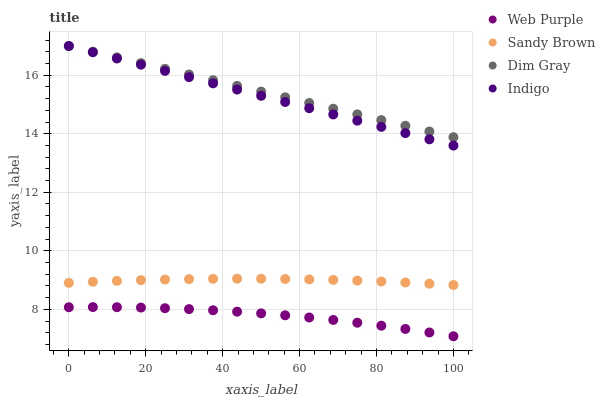Does Web Purple have the minimum area under the curve?
Answer yes or no. Yes. Does Dim Gray have the maximum area under the curve?
Answer yes or no. Yes. Does Dim Gray have the minimum area under the curve?
Answer yes or no. No. Does Web Purple have the maximum area under the curve?
Answer yes or no. No. Is Indigo the smoothest?
Answer yes or no. Yes. Is Web Purple the roughest?
Answer yes or no. Yes. Is Web Purple the smoothest?
Answer yes or no. No. Is Dim Gray the roughest?
Answer yes or no. No. Does Web Purple have the lowest value?
Answer yes or no. Yes. Does Dim Gray have the lowest value?
Answer yes or no. No. Does Dim Gray have the highest value?
Answer yes or no. Yes. Does Web Purple have the highest value?
Answer yes or no. No. Is Web Purple less than Dim Gray?
Answer yes or no. Yes. Is Indigo greater than Web Purple?
Answer yes or no. Yes. Does Dim Gray intersect Indigo?
Answer yes or no. Yes. Is Dim Gray less than Indigo?
Answer yes or no. No. Is Dim Gray greater than Indigo?
Answer yes or no. No. Does Web Purple intersect Dim Gray?
Answer yes or no. No. 